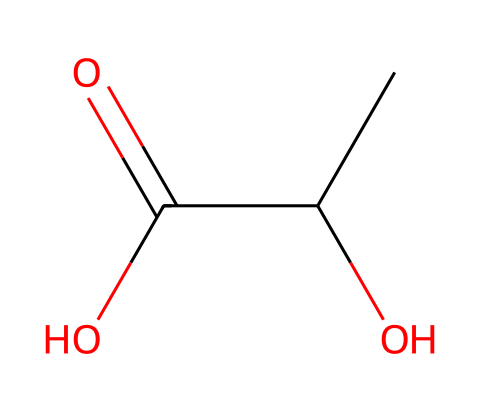What is the main functional group present in this monomer? The structure features a carboxylic acid group (–COOH), which is characterized by a carbon atom double-bonded to an oxygen atom and single-bonded to a hydroxyl group (–OH). This functional group is crucial for the acidity of the compound.
Answer: carboxylic acid How many carbon atoms are in this monomer? The SMILES representation shows a chain of carbon atoms. Counting the "C" symbols in the structure indicates there are three carbon atoms total.
Answer: three What type of chemical reaction can this monomer undergo to form PLA? The carboxylic acid group present can react with an alcohol group through a condensation reaction to form an ester linkage, which is essential in the polymerization of PLA.
Answer: condensation How many hydrogen atoms are present in this monomer? Each carbon typically bonds with hydrogen to complete its tetravalency. The structure indicates there are five hydrogen atoms associated with the three carbon atoms, taking into account the functional groups that are not available for hydrogen bonding.
Answer: five What is the significance of the hydroxyl group in the chemical structure? The hydroxyl group (–OH) is important because it contributes to the hydrophilic nature of PLA and can influence its interactions with water and biodegradability.
Answer: hydrophilic Is this monomer polar or nonpolar? The presence of the carboxylic acid and hydroxyl groups in the structure makes the monomer polar, as these functional groups are capable of hydrogen bonding and increase the molecule's overall dipole moment.
Answer: polar 